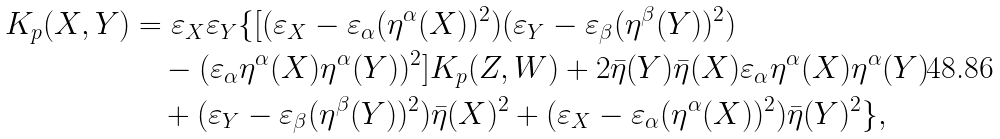<formula> <loc_0><loc_0><loc_500><loc_500>K _ { p } ( X , Y ) & = \varepsilon _ { X } \varepsilon _ { Y } \{ [ ( \varepsilon _ { X } - \varepsilon _ { \alpha } ( { \eta } ^ { \alpha } ( X ) ) ^ { 2 } ) ( \varepsilon _ { Y } - \varepsilon _ { \beta } ( { \eta } ^ { \beta } ( Y ) ) ^ { 2 } ) \\ & \quad - ( \varepsilon _ { \alpha } { \eta } ^ { \alpha } ( X ) { \eta } ^ { \alpha } ( Y ) ) ^ { 2 } ] K _ { p } ( Z , W ) + 2 \bar { \eta } ( Y ) \bar { \eta } ( X ) \varepsilon _ { \alpha } { \eta } ^ { \alpha } ( X ) { \eta } ^ { \alpha } ( Y ) \\ & \quad + ( \varepsilon _ { Y } - \varepsilon _ { \beta } ( { \eta } ^ { \beta } ( Y ) ) ^ { 2 } ) \bar { \eta } ( X ) ^ { 2 } + ( \varepsilon _ { X } - \varepsilon _ { \alpha } ( { \eta } ^ { \alpha } ( X ) ) ^ { 2 } ) \bar { \eta } ( Y ) ^ { 2 } \} ,</formula> 